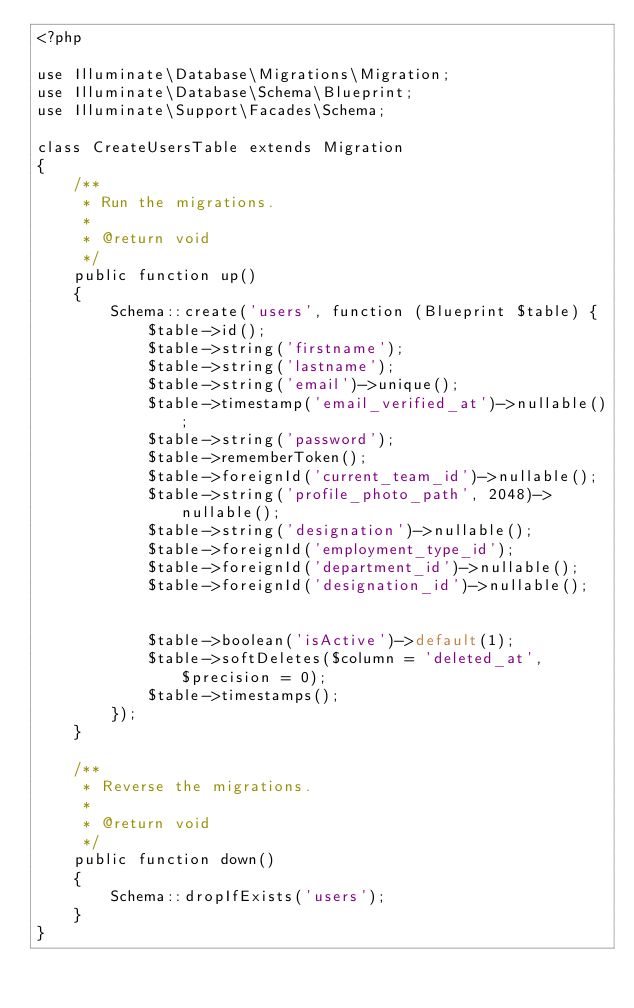Convert code to text. <code><loc_0><loc_0><loc_500><loc_500><_PHP_><?php

use Illuminate\Database\Migrations\Migration;
use Illuminate\Database\Schema\Blueprint;
use Illuminate\Support\Facades\Schema;

class CreateUsersTable extends Migration
{
    /**
     * Run the migrations.
     *
     * @return void
     */
    public function up()
    {
        Schema::create('users', function (Blueprint $table) {
            $table->id();
            $table->string('firstname');
            $table->string('lastname');
            $table->string('email')->unique();
            $table->timestamp('email_verified_at')->nullable();
            $table->string('password');
            $table->rememberToken();
            $table->foreignId('current_team_id')->nullable();
            $table->string('profile_photo_path', 2048)->nullable();
            $table->string('designation')->nullable();
            $table->foreignId('employment_type_id');
            $table->foreignId('department_id')->nullable();
            $table->foreignId('designation_id')->nullable();


            $table->boolean('isActive')->default(1);
            $table->softDeletes($column = 'deleted_at', $precision = 0);
            $table->timestamps();
        });
    }

    /**
     * Reverse the migrations.
     *
     * @return void
     */
    public function down()
    {
        Schema::dropIfExists('users');
    }
}
</code> 